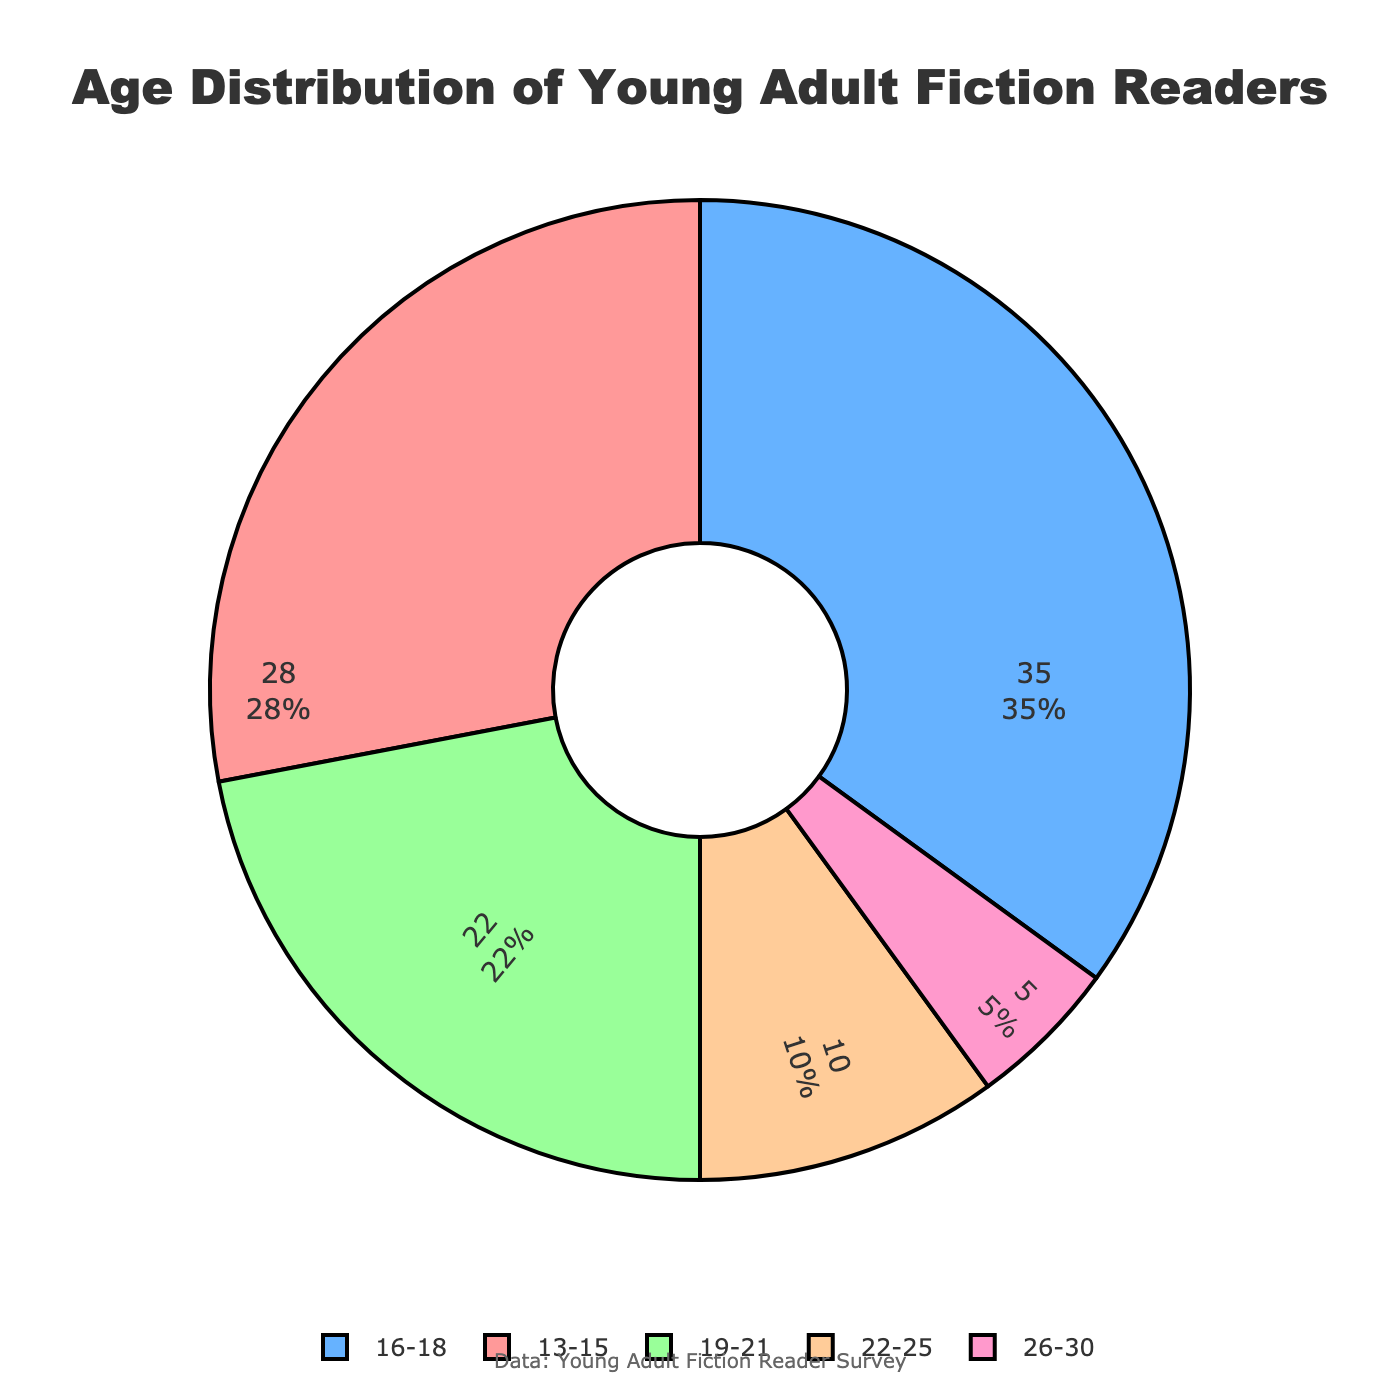Which age group constitutes the largest percentage of young adult fiction readers? The figure shows that the 16-18 age group is represented by the largest segment of the pie chart. By hovering over the segment, it reveals that this group constitutes 35% of the readers.
Answer: 16-18 What is the combined percentage of young adult fiction readers between the ages of 19 and 25? The figure shows that the 19-21 age group constitutes 22% and the 22-25 age group constitutes 10%. Summing these two percentages, we get 22% + 10% = 32%.
Answer: 32% Which age group makes up the smallest portion of young adult fiction readers? By observing the pie chart, the smallest segment is clearly marked for the 26-30 age group, which accounts for 5% of the readers.
Answer: 26-30 How does the percentage of readers aged 13-15 compare to those aged 19-21? The pie chart shows that 13-15 year-olds constitute 28% of readers while 19-21 year-olds make up 22%. 28% is higher than 22%, indicating that there are more readers in the 13-15 age group than in the 19-21 age group.
Answer: 13-15 is greater than 19-21 What proportion of the readers are 22 years or older? The pie chart indicates that 10% of readers are in the 22-25 age group and 5% are in the 26-30 age group. Summing these percentages, we get 10% + 5% = 15%.
Answer: 15% Is there a significant visual difference between the segments for ages 13-15 and ages 26-30? Visually, the segment for the 13-15 age group is much larger than the segment for the 26-30 age group. This is consistent with the data showing that 28% of readers are aged 13-15, compared to only 5% aged 26-30.
Answer: Yes What is the average percentage of readers in the first three age groups (13-15, 16-18, 19-21)? Add the percentages of the 13-15, 16-18, and 19-21 age groups: 28% + 35% + 22% = 85%. There are three groups, so the average is 85% / 3 = 28.33%.
Answer: 28.33% What percentage of readers fall into the younger half of the age distribution (13-21)? The younger half consists of the 13-15, 16-18, and 19-21 age groups. Summing their percentages, we get 28% + 35% + 22% = 85%.
Answer: 85% Compare the number of readers aged 16-18 to the combined number of readers aged 22-30. The 16-18 age group constitutes 35% of readers. The 22-25 group is 10% and the 26-30 group is 5%, making a combined percentage of 10% + 5% = 15% for ages 22-30. Therefore, 35% is significantly greater than 15%.
Answer: 16-18 is greater 